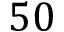<formula> <loc_0><loc_0><loc_500><loc_500>5 0</formula> 